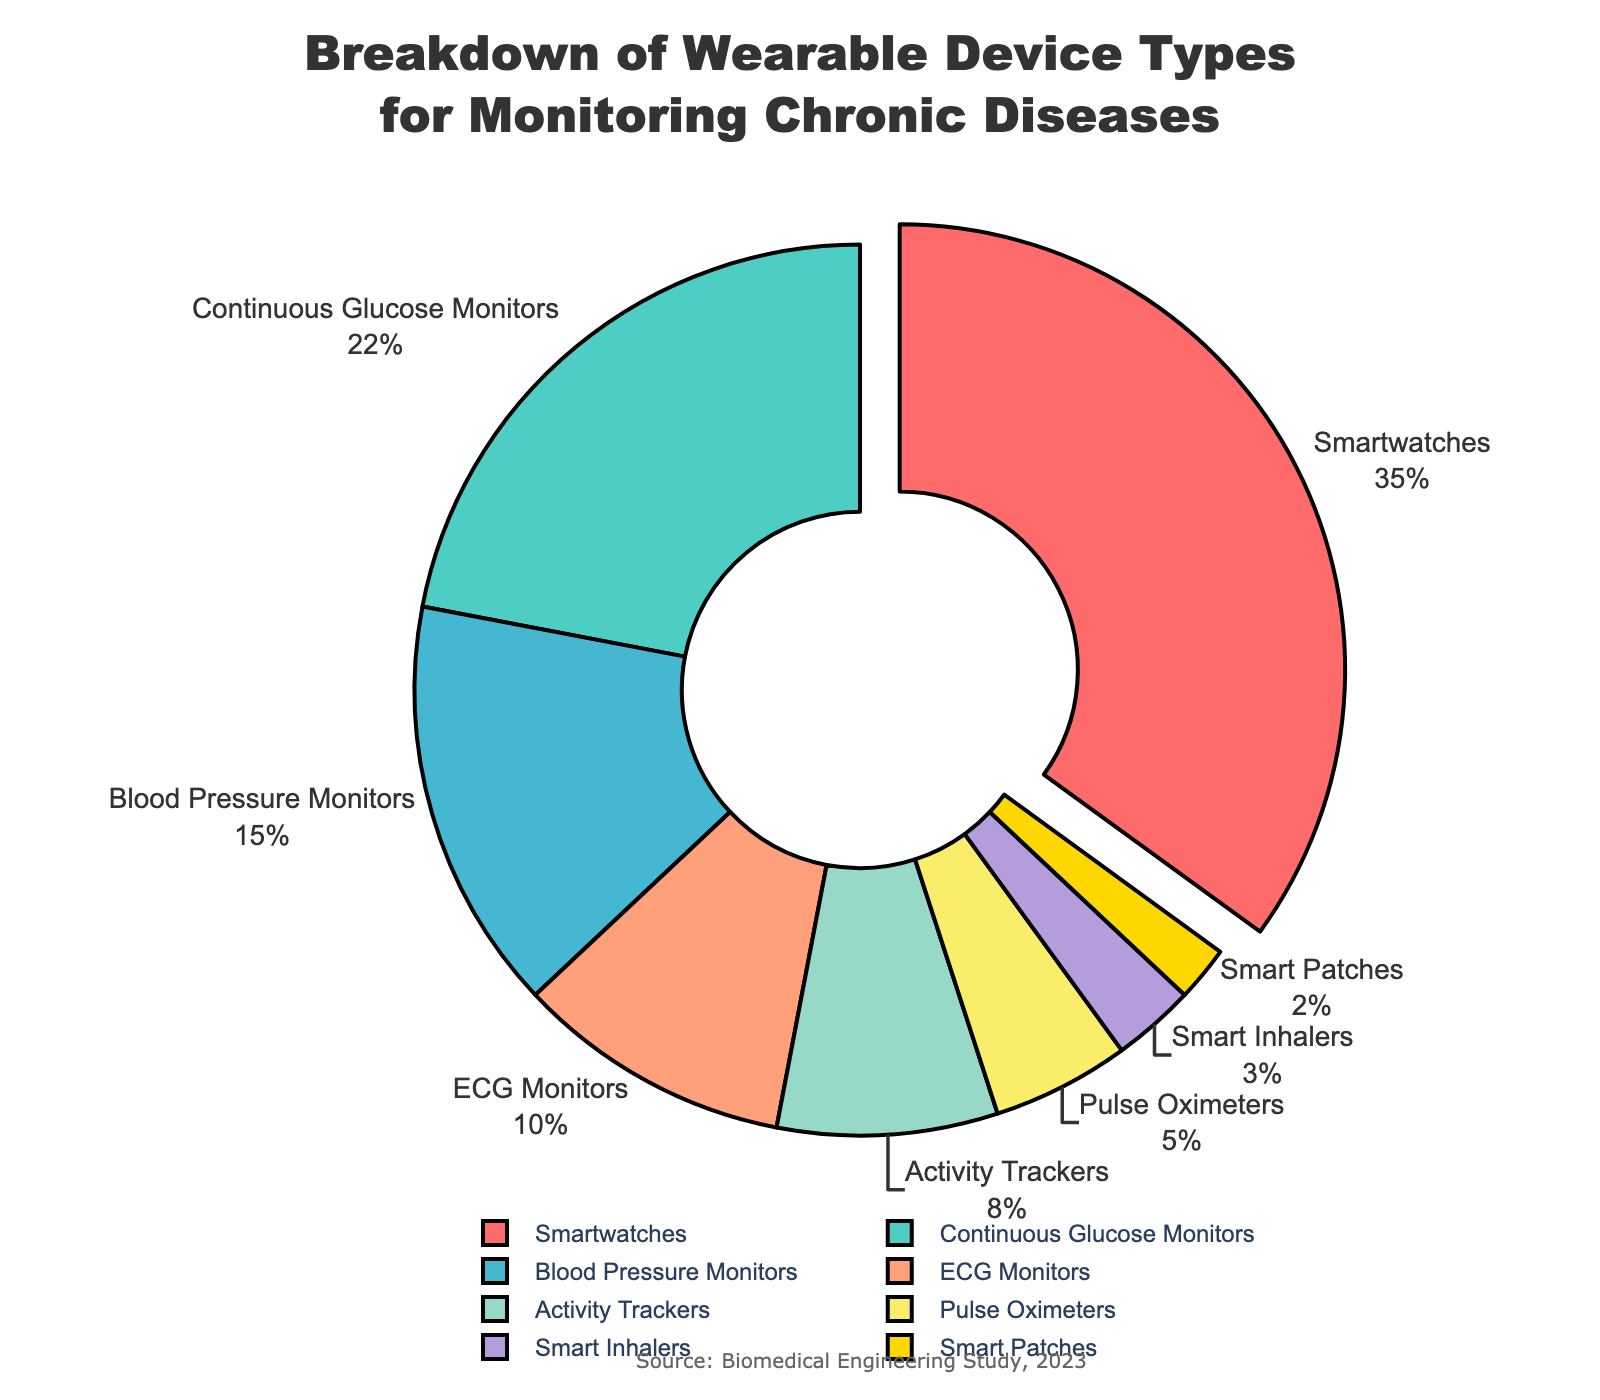What is the most commonly used wearable device for monitoring chronic diseases? The most commonly used wearable device can be identified by looking at the segment with the largest percentage in the pie chart. Smartwatches have the largest segment, making up 35% of the total.
Answer: Smartwatches Which device has a larger percentage, Continuous Glucose Monitors or Blood Pressure Monitors? Compare the segments representing Continuous Glucose Monitors and Blood Pressure Monitors. Continuous Glucose Monitors have a percentage of 22%, while Blood Pressure Monitors have 15%, so the former has a larger percentage.
Answer: Continuous Glucose Monitors What is the combined percentage of Activity Trackers, Pulse Oximeters, Smart Inhalers, and Smart Patches? Sum up the percentages for Activity Trackers (8%), Pulse Oximeters (5%), Smart Inhalers (3%), and Smart Patches (2%). 8 + 5 + 3 + 2 = 18%.
Answer: 18% What is the difference in percentage between Smartwatches and ECG Monitors? Subtract the percentage of ECG Monitors (10%) from the percentage of Smartwatches (35%). 35 - 10 = 25%.
Answer: 25% How does the percentage of Pulse Oximeters compare to that of Activity Trackers? Compare the segments representing Pulse Oximeters and Activity Trackers. Pulse Oximeters have 5%, while Activity Trackers have 8%. Since 5% is less than 8%, Pulse Oximeters have a smaller percentage.
Answer: Pulse Oximeters have a smaller percentage Based on their percentage, which device types collectively make up more than half of the total? Sum the percentages of the largest segments until the sum exceeds 50%. Smartwatches (35%) + Continuous Glucose Monitors (22%) = 57%, which is already more than half. Thus, these two device types collectively make up more than half.
Answer: Smartwatches and Continuous Glucose Monitors Which device type has the smallest percentage? Identify the segment with the smallest percentage. Smart Patches have the smallest segment, making up 2% of the total.
Answer: Smart Patches What is the visual indication that highlights Smartwatches as the most commonly used device type? The segment for Smartwatches is pulled slightly away from the pie chart, emphasizing its importance visually.
Answer: The segment for Smartwatches is pulled out If a new wearable device type is introduced and it takes over 5% of the share, which current device type(s) will it surpass in percentage? Identify the device types with percentages less than or equal to 5%. Pulse Oximeters (5%), Smart Inhalers (3%), and Smart Patches (2%) will all be surpassed if a new device type takes over 5%.
Answer: Pulse Oximeters, Smart Inhalers, and Smart Patches 